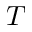<formula> <loc_0><loc_0><loc_500><loc_500>T</formula> 